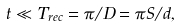<formula> <loc_0><loc_0><loc_500><loc_500>t \ll T _ { r e c } = \pi / D = \pi S / d ,</formula> 